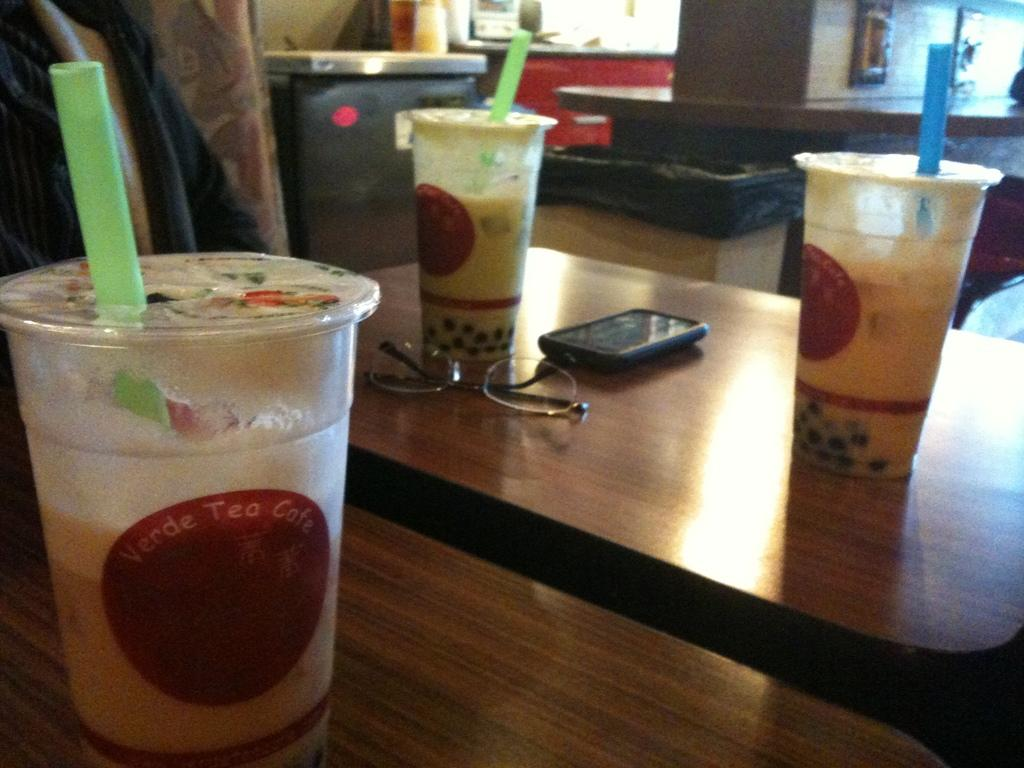<image>
Create a compact narrative representing the image presented. Three cups from Verde Tea Cafe on tables with phone and glasses near two of the cups. 